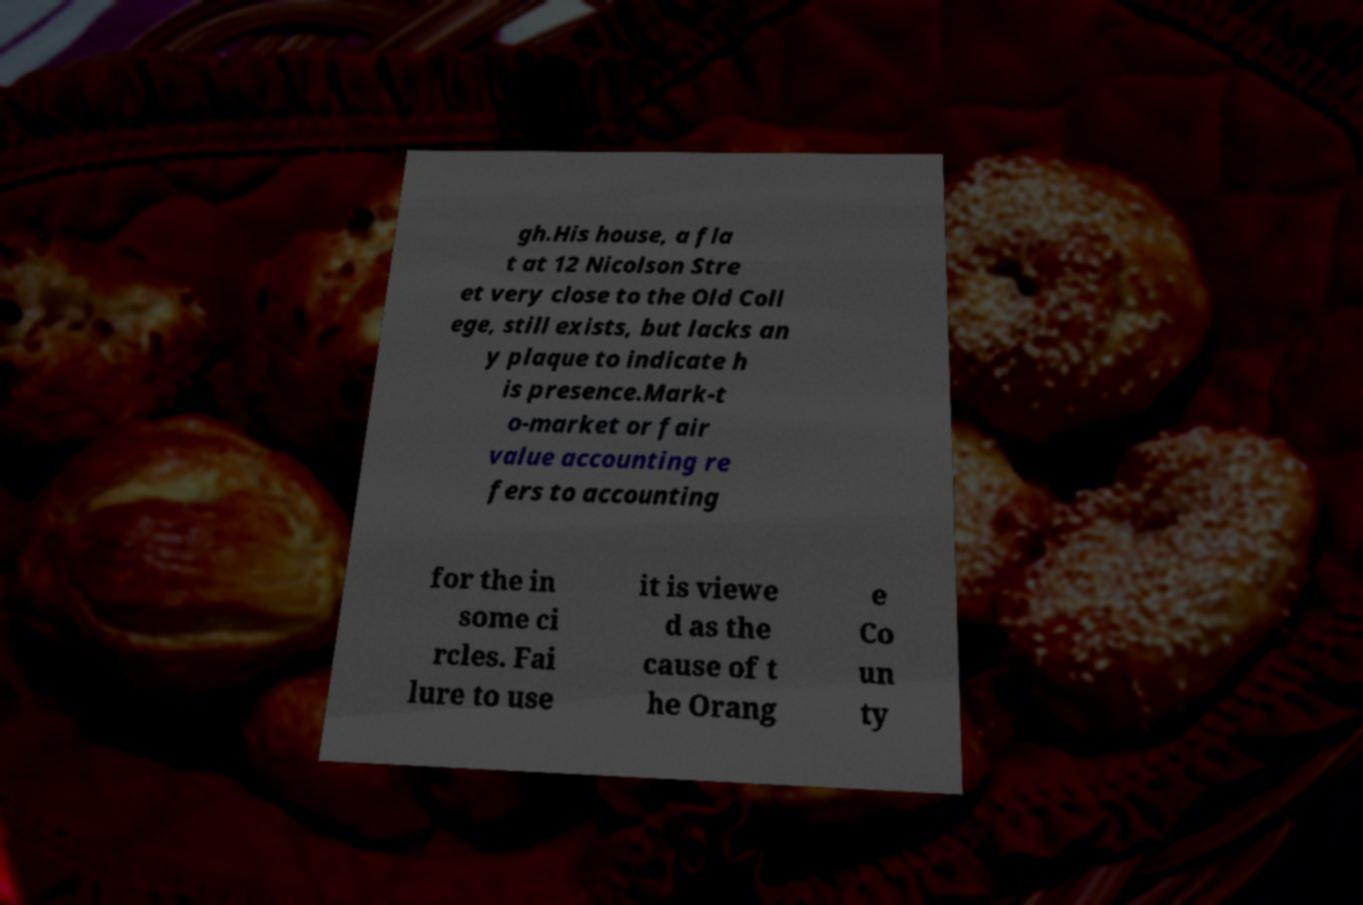Please read and relay the text visible in this image. What does it say? gh.His house, a fla t at 12 Nicolson Stre et very close to the Old Coll ege, still exists, but lacks an y plaque to indicate h is presence.Mark-t o-market or fair value accounting re fers to accounting for the in some ci rcles. Fai lure to use it is viewe d as the cause of t he Orang e Co un ty 